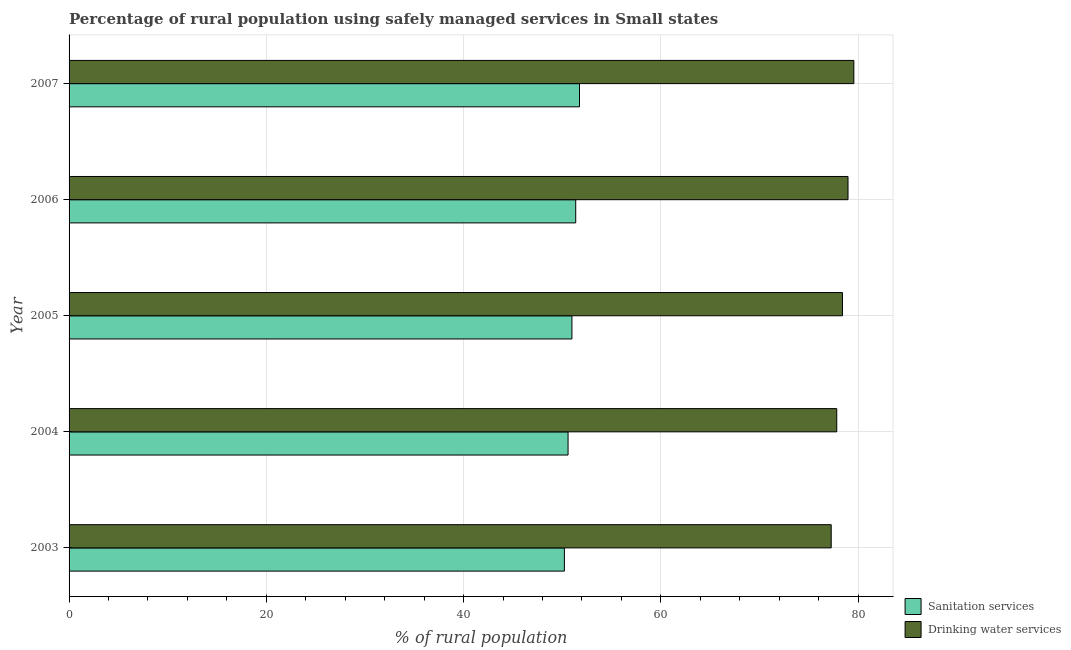Are the number of bars per tick equal to the number of legend labels?
Ensure brevity in your answer.  Yes. Are the number of bars on each tick of the Y-axis equal?
Provide a succinct answer. Yes. How many bars are there on the 5th tick from the bottom?
Offer a terse response. 2. What is the label of the 2nd group of bars from the top?
Give a very brief answer. 2006. In how many cases, is the number of bars for a given year not equal to the number of legend labels?
Your answer should be compact. 0. What is the percentage of rural population who used drinking water services in 2006?
Keep it short and to the point. 78.97. Across all years, what is the maximum percentage of rural population who used drinking water services?
Provide a short and direct response. 79.56. Across all years, what is the minimum percentage of rural population who used drinking water services?
Give a very brief answer. 77.27. In which year was the percentage of rural population who used sanitation services maximum?
Ensure brevity in your answer.  2007. What is the total percentage of rural population who used drinking water services in the graph?
Ensure brevity in your answer.  392.05. What is the difference between the percentage of rural population who used drinking water services in 2004 and that in 2005?
Your answer should be very brief. -0.58. What is the difference between the percentage of rural population who used sanitation services in 2006 and the percentage of rural population who used drinking water services in 2007?
Provide a succinct answer. -28.2. What is the average percentage of rural population who used drinking water services per year?
Your answer should be very brief. 78.41. In the year 2006, what is the difference between the percentage of rural population who used sanitation services and percentage of rural population who used drinking water services?
Make the answer very short. -27.61. In how many years, is the percentage of rural population who used drinking water services greater than 36 %?
Make the answer very short. 5. What is the ratio of the percentage of rural population who used sanitation services in 2003 to that in 2004?
Offer a very short reply. 0.99. Is the percentage of rural population who used drinking water services in 2004 less than that in 2007?
Your answer should be compact. Yes. Is the difference between the percentage of rural population who used drinking water services in 2003 and 2004 greater than the difference between the percentage of rural population who used sanitation services in 2003 and 2004?
Keep it short and to the point. No. What is the difference between the highest and the second highest percentage of rural population who used drinking water services?
Ensure brevity in your answer.  0.59. What is the difference between the highest and the lowest percentage of rural population who used sanitation services?
Make the answer very short. 1.53. In how many years, is the percentage of rural population who used sanitation services greater than the average percentage of rural population who used sanitation services taken over all years?
Your answer should be compact. 2. Is the sum of the percentage of rural population who used sanitation services in 2005 and 2006 greater than the maximum percentage of rural population who used drinking water services across all years?
Offer a terse response. Yes. What does the 1st bar from the top in 2007 represents?
Your answer should be compact. Drinking water services. What does the 1st bar from the bottom in 2004 represents?
Your response must be concise. Sanitation services. How many bars are there?
Give a very brief answer. 10. Are all the bars in the graph horizontal?
Offer a terse response. Yes. Are the values on the major ticks of X-axis written in scientific E-notation?
Your response must be concise. No. Does the graph contain any zero values?
Keep it short and to the point. No. Where does the legend appear in the graph?
Provide a succinct answer. Bottom right. How many legend labels are there?
Keep it short and to the point. 2. How are the legend labels stacked?
Provide a succinct answer. Vertical. What is the title of the graph?
Make the answer very short. Percentage of rural population using safely managed services in Small states. What is the label or title of the X-axis?
Ensure brevity in your answer.  % of rural population. What is the label or title of the Y-axis?
Your answer should be compact. Year. What is the % of rural population in Sanitation services in 2003?
Offer a very short reply. 50.22. What is the % of rural population of Drinking water services in 2003?
Make the answer very short. 77.27. What is the % of rural population of Sanitation services in 2004?
Give a very brief answer. 50.59. What is the % of rural population in Drinking water services in 2004?
Provide a succinct answer. 77.83. What is the % of rural population in Sanitation services in 2005?
Offer a terse response. 50.98. What is the % of rural population of Drinking water services in 2005?
Offer a very short reply. 78.41. What is the % of rural population of Sanitation services in 2006?
Offer a terse response. 51.37. What is the % of rural population of Drinking water services in 2006?
Ensure brevity in your answer.  78.97. What is the % of rural population in Sanitation services in 2007?
Offer a terse response. 51.75. What is the % of rural population in Drinking water services in 2007?
Provide a short and direct response. 79.56. Across all years, what is the maximum % of rural population in Sanitation services?
Offer a very short reply. 51.75. Across all years, what is the maximum % of rural population in Drinking water services?
Make the answer very short. 79.56. Across all years, what is the minimum % of rural population in Sanitation services?
Provide a succinct answer. 50.22. Across all years, what is the minimum % of rural population in Drinking water services?
Make the answer very short. 77.27. What is the total % of rural population of Sanitation services in the graph?
Your response must be concise. 254.91. What is the total % of rural population of Drinking water services in the graph?
Your answer should be very brief. 392.05. What is the difference between the % of rural population in Sanitation services in 2003 and that in 2004?
Your answer should be very brief. -0.37. What is the difference between the % of rural population in Drinking water services in 2003 and that in 2004?
Your answer should be compact. -0.56. What is the difference between the % of rural population of Sanitation services in 2003 and that in 2005?
Your answer should be compact. -0.76. What is the difference between the % of rural population in Drinking water services in 2003 and that in 2005?
Offer a terse response. -1.14. What is the difference between the % of rural population in Sanitation services in 2003 and that in 2006?
Your answer should be very brief. -1.15. What is the difference between the % of rural population of Drinking water services in 2003 and that in 2006?
Provide a short and direct response. -1.7. What is the difference between the % of rural population of Sanitation services in 2003 and that in 2007?
Ensure brevity in your answer.  -1.53. What is the difference between the % of rural population of Drinking water services in 2003 and that in 2007?
Provide a succinct answer. -2.29. What is the difference between the % of rural population of Sanitation services in 2004 and that in 2005?
Ensure brevity in your answer.  -0.39. What is the difference between the % of rural population in Drinking water services in 2004 and that in 2005?
Provide a short and direct response. -0.58. What is the difference between the % of rural population in Sanitation services in 2004 and that in 2006?
Provide a succinct answer. -0.78. What is the difference between the % of rural population in Drinking water services in 2004 and that in 2006?
Ensure brevity in your answer.  -1.14. What is the difference between the % of rural population in Sanitation services in 2004 and that in 2007?
Your response must be concise. -1.16. What is the difference between the % of rural population of Drinking water services in 2004 and that in 2007?
Make the answer very short. -1.73. What is the difference between the % of rural population in Sanitation services in 2005 and that in 2006?
Keep it short and to the point. -0.39. What is the difference between the % of rural population in Drinking water services in 2005 and that in 2006?
Your response must be concise. -0.56. What is the difference between the % of rural population of Sanitation services in 2005 and that in 2007?
Your answer should be compact. -0.77. What is the difference between the % of rural population of Drinking water services in 2005 and that in 2007?
Ensure brevity in your answer.  -1.15. What is the difference between the % of rural population in Sanitation services in 2006 and that in 2007?
Offer a very short reply. -0.38. What is the difference between the % of rural population in Drinking water services in 2006 and that in 2007?
Provide a short and direct response. -0.59. What is the difference between the % of rural population of Sanitation services in 2003 and the % of rural population of Drinking water services in 2004?
Provide a short and direct response. -27.61. What is the difference between the % of rural population of Sanitation services in 2003 and the % of rural population of Drinking water services in 2005?
Make the answer very short. -28.19. What is the difference between the % of rural population in Sanitation services in 2003 and the % of rural population in Drinking water services in 2006?
Offer a very short reply. -28.76. What is the difference between the % of rural population in Sanitation services in 2003 and the % of rural population in Drinking water services in 2007?
Provide a short and direct response. -29.35. What is the difference between the % of rural population in Sanitation services in 2004 and the % of rural population in Drinking water services in 2005?
Ensure brevity in your answer.  -27.82. What is the difference between the % of rural population in Sanitation services in 2004 and the % of rural population in Drinking water services in 2006?
Provide a short and direct response. -28.38. What is the difference between the % of rural population in Sanitation services in 2004 and the % of rural population in Drinking water services in 2007?
Ensure brevity in your answer.  -28.97. What is the difference between the % of rural population of Sanitation services in 2005 and the % of rural population of Drinking water services in 2006?
Provide a short and direct response. -27.99. What is the difference between the % of rural population of Sanitation services in 2005 and the % of rural population of Drinking water services in 2007?
Your answer should be very brief. -28.58. What is the difference between the % of rural population in Sanitation services in 2006 and the % of rural population in Drinking water services in 2007?
Ensure brevity in your answer.  -28.2. What is the average % of rural population of Sanitation services per year?
Provide a succinct answer. 50.98. What is the average % of rural population in Drinking water services per year?
Offer a very short reply. 78.41. In the year 2003, what is the difference between the % of rural population in Sanitation services and % of rural population in Drinking water services?
Your answer should be compact. -27.05. In the year 2004, what is the difference between the % of rural population of Sanitation services and % of rural population of Drinking water services?
Keep it short and to the point. -27.24. In the year 2005, what is the difference between the % of rural population in Sanitation services and % of rural population in Drinking water services?
Provide a succinct answer. -27.43. In the year 2006, what is the difference between the % of rural population in Sanitation services and % of rural population in Drinking water services?
Your answer should be compact. -27.61. In the year 2007, what is the difference between the % of rural population in Sanitation services and % of rural population in Drinking water services?
Offer a very short reply. -27.81. What is the ratio of the % of rural population of Sanitation services in 2003 to that in 2004?
Ensure brevity in your answer.  0.99. What is the ratio of the % of rural population of Sanitation services in 2003 to that in 2005?
Your response must be concise. 0.98. What is the ratio of the % of rural population in Drinking water services in 2003 to that in 2005?
Ensure brevity in your answer.  0.99. What is the ratio of the % of rural population in Sanitation services in 2003 to that in 2006?
Your answer should be very brief. 0.98. What is the ratio of the % of rural population of Drinking water services in 2003 to that in 2006?
Keep it short and to the point. 0.98. What is the ratio of the % of rural population in Sanitation services in 2003 to that in 2007?
Offer a terse response. 0.97. What is the ratio of the % of rural population in Drinking water services in 2003 to that in 2007?
Keep it short and to the point. 0.97. What is the ratio of the % of rural population in Sanitation services in 2004 to that in 2005?
Give a very brief answer. 0.99. What is the ratio of the % of rural population in Sanitation services in 2004 to that in 2006?
Make the answer very short. 0.98. What is the ratio of the % of rural population of Drinking water services in 2004 to that in 2006?
Offer a very short reply. 0.99. What is the ratio of the % of rural population of Sanitation services in 2004 to that in 2007?
Provide a succinct answer. 0.98. What is the ratio of the % of rural population in Drinking water services in 2004 to that in 2007?
Your answer should be very brief. 0.98. What is the ratio of the % of rural population in Sanitation services in 2005 to that in 2006?
Your response must be concise. 0.99. What is the ratio of the % of rural population of Sanitation services in 2005 to that in 2007?
Offer a terse response. 0.99. What is the ratio of the % of rural population of Drinking water services in 2005 to that in 2007?
Offer a terse response. 0.99. What is the difference between the highest and the second highest % of rural population of Sanitation services?
Keep it short and to the point. 0.38. What is the difference between the highest and the second highest % of rural population in Drinking water services?
Provide a succinct answer. 0.59. What is the difference between the highest and the lowest % of rural population in Sanitation services?
Keep it short and to the point. 1.53. What is the difference between the highest and the lowest % of rural population in Drinking water services?
Offer a terse response. 2.29. 